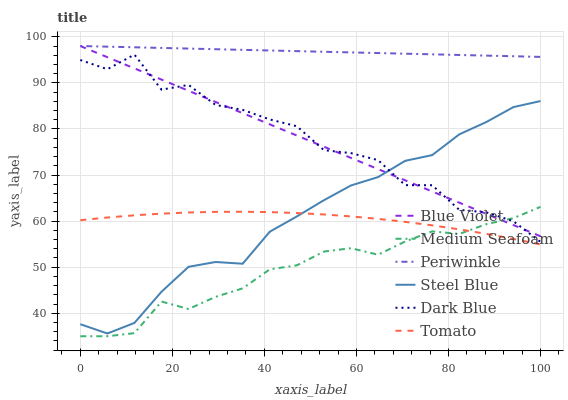Does Medium Seafoam have the minimum area under the curve?
Answer yes or no. Yes. Does Periwinkle have the maximum area under the curve?
Answer yes or no. Yes. Does Steel Blue have the minimum area under the curve?
Answer yes or no. No. Does Steel Blue have the maximum area under the curve?
Answer yes or no. No. Is Periwinkle the smoothest?
Answer yes or no. Yes. Is Dark Blue the roughest?
Answer yes or no. Yes. Is Steel Blue the smoothest?
Answer yes or no. No. Is Steel Blue the roughest?
Answer yes or no. No. Does Steel Blue have the lowest value?
Answer yes or no. No. Does Blue Violet have the highest value?
Answer yes or no. Yes. Does Steel Blue have the highest value?
Answer yes or no. No. Is Medium Seafoam less than Periwinkle?
Answer yes or no. Yes. Is Dark Blue greater than Tomato?
Answer yes or no. Yes. Does Dark Blue intersect Blue Violet?
Answer yes or no. Yes. Is Dark Blue less than Blue Violet?
Answer yes or no. No. Is Dark Blue greater than Blue Violet?
Answer yes or no. No. Does Medium Seafoam intersect Periwinkle?
Answer yes or no. No. 